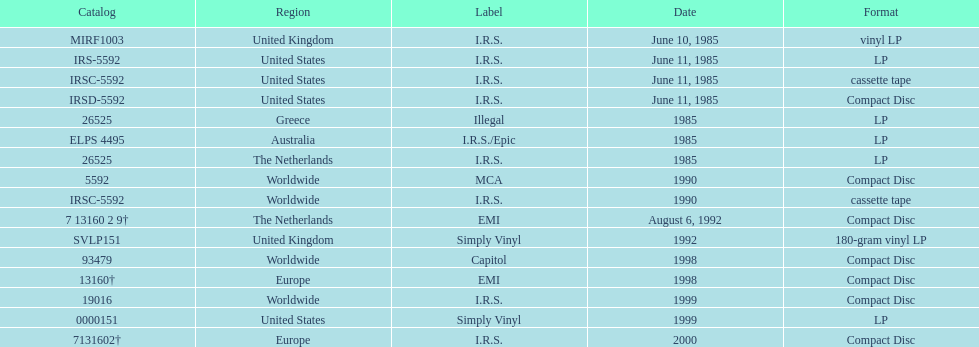Would you mind parsing the complete table? {'header': ['Catalog', 'Region', 'Label', 'Date', 'Format'], 'rows': [['MIRF1003', 'United Kingdom', 'I.R.S.', 'June 10, 1985', 'vinyl LP'], ['IRS-5592', 'United States', 'I.R.S.', 'June 11, 1985', 'LP'], ['IRSC-5592', 'United States', 'I.R.S.', 'June 11, 1985', 'cassette tape'], ['IRSD-5592', 'United States', 'I.R.S.', 'June 11, 1985', 'Compact Disc'], ['26525', 'Greece', 'Illegal', '1985', 'LP'], ['ELPS 4495', 'Australia', 'I.R.S./Epic', '1985', 'LP'], ['26525', 'The Netherlands', 'I.R.S.', '1985', 'LP'], ['5592', 'Worldwide', 'MCA', '1990', 'Compact Disc'], ['IRSC-5592', 'Worldwide', 'I.R.S.', '1990', 'cassette tape'], ['7 13160 2 9†', 'The Netherlands', 'EMI', 'August 6, 1992', 'Compact Disc'], ['SVLP151', 'United Kingdom', 'Simply Vinyl', '1992', '180-gram vinyl LP'], ['93479', 'Worldwide', 'Capitol', '1998', 'Compact Disc'], ['13160†', 'Europe', 'EMI', '1998', 'Compact Disc'], ['19016', 'Worldwide', 'I.R.S.', '1999', 'Compact Disc'], ['0000151', 'United States', 'Simply Vinyl', '1999', 'LP'], ['7131602†', 'Europe', 'I.R.S.', '2000', 'Compact Disc']]} Which is the only region with vinyl lp format? United Kingdom. 